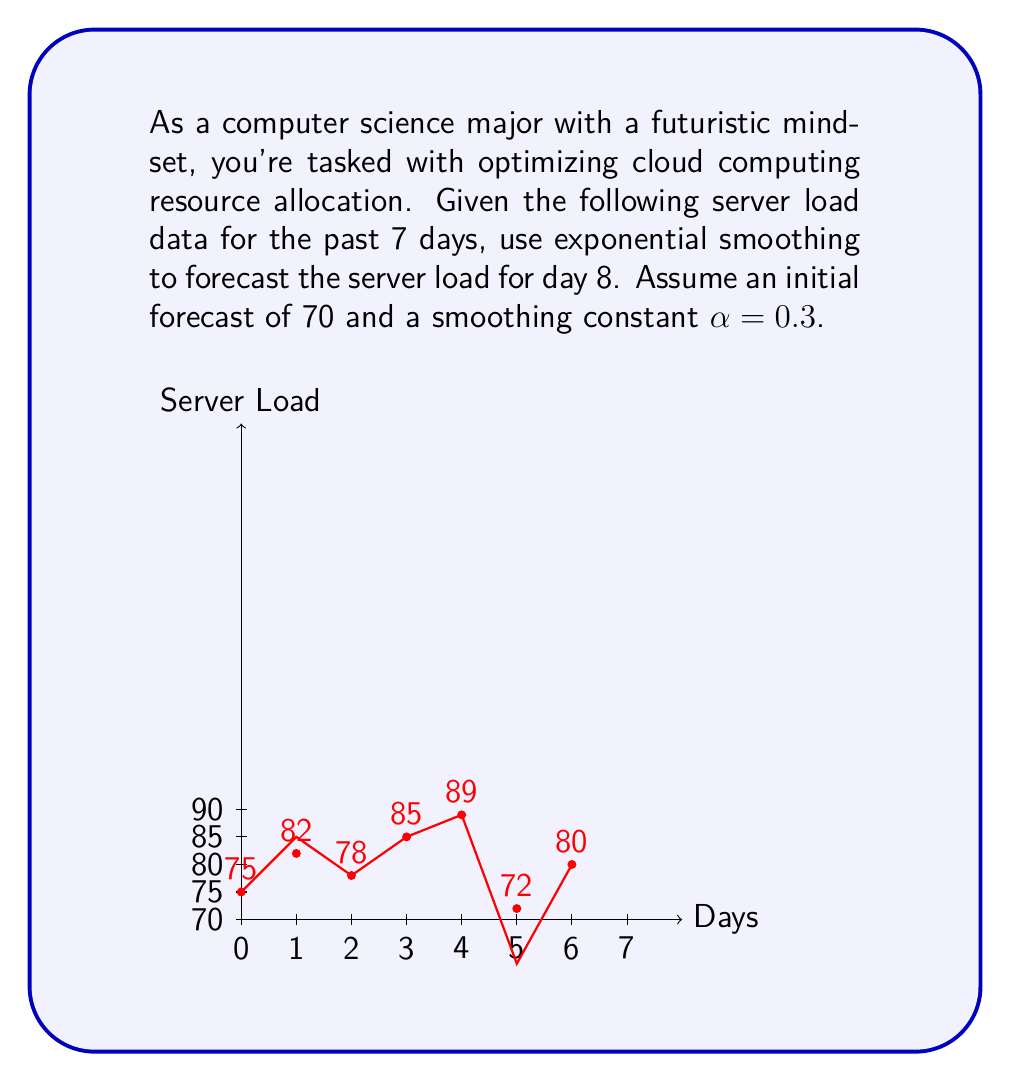Can you answer this question? Let's approach this step-by-step using exponential smoothing:

1) The exponential smoothing formula is:
   $$F_t = αY_{t-1} + (1-α)F_{t-1}$$
   Where:
   $F_t$ is the forecast for period t
   $Y_{t-1}$ is the actual value in period t-1
   $α$ is the smoothing constant (0 < α < 1)

2) Given:
   - Initial forecast $F_1 = 70$
   - Smoothing constant α = 0.3

3) Let's calculate the forecast for each day:

   Day 1: $F_1 = 70$ (given)
   
   Day 2: $F_2 = 0.3(75) + 0.7(70) = 71.5$
   
   Day 3: $F_3 = 0.3(82) + 0.7(71.5) = 74.65$
   
   Day 4: $F_4 = 0.3(78) + 0.7(74.65) = 75.655$
   
   Day 5: $F_5 = 0.3(85) + 0.7(75.655) = 78.4585$
   
   Day 6: $F_6 = 0.3(89) + 0.7(78.4585) = 81.62095$
   
   Day 7: $F_7 = 0.3(72) + 0.7(81.62095) = 78.734665$
   
   Day 8: $F_8 = 0.3(80) + 0.7(78.734665) = 79.1142655$

4) Therefore, the forecast for day 8 is approximately 79.11.
Answer: 79.11 